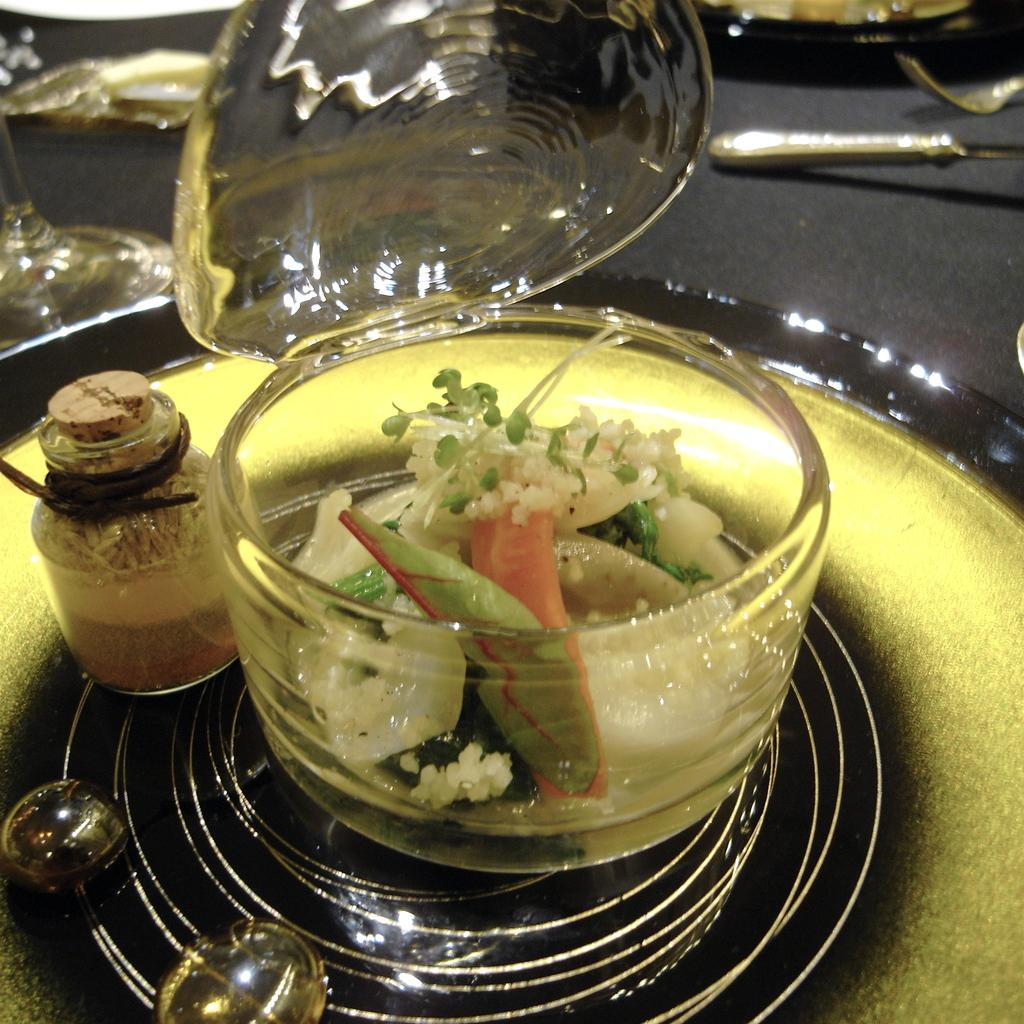What is the main object in the center of the image? There is a table in the center of the image. What can be found on the table? On the table, there is a plate, a bowl, a jar, and a glass. What type of items are on the table? There are food items and other objects on the table. What is the name of the son who lives downtown and is often surrounded by mist in the image? There is no son, downtown location, or mist present in the image. 